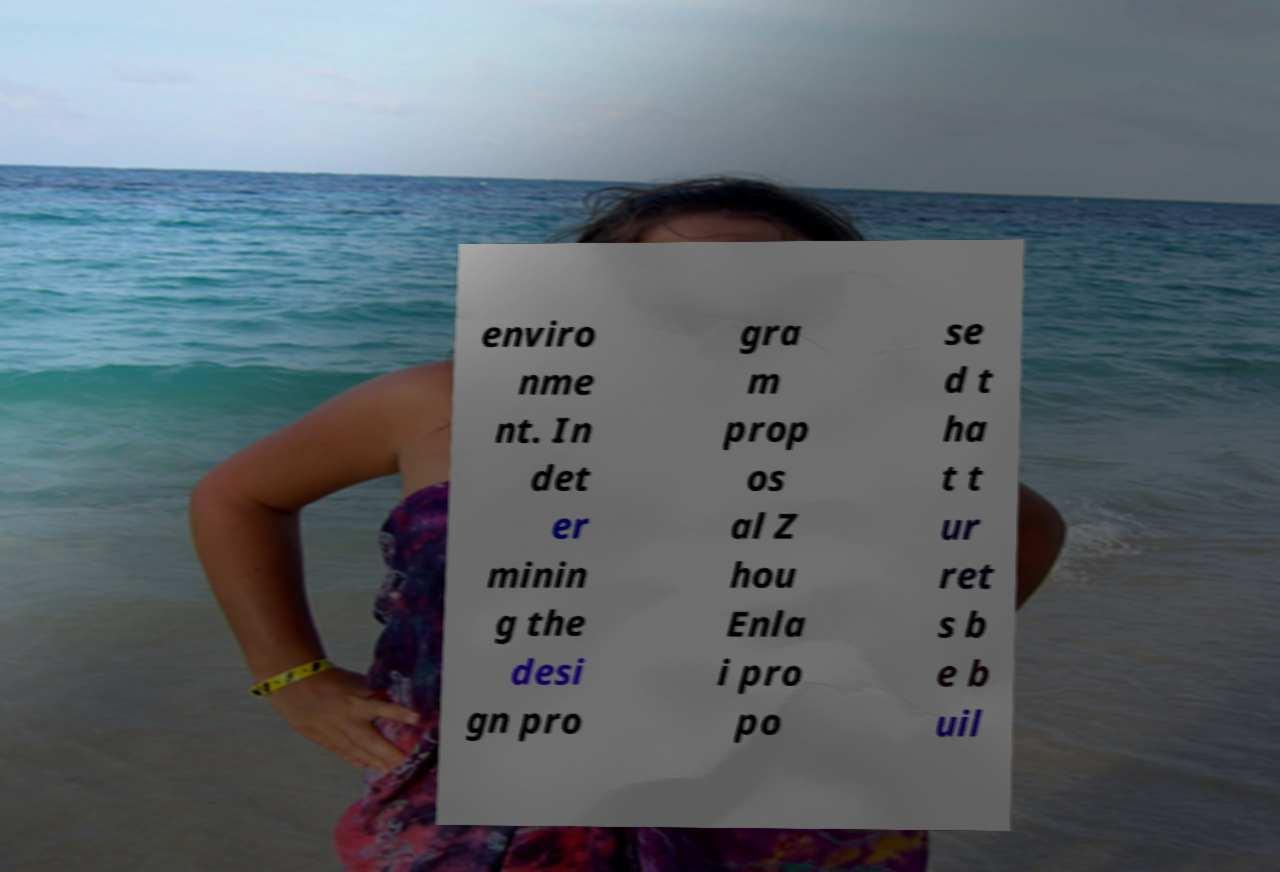Could you assist in decoding the text presented in this image and type it out clearly? enviro nme nt. In det er minin g the desi gn pro gra m prop os al Z hou Enla i pro po se d t ha t t ur ret s b e b uil 